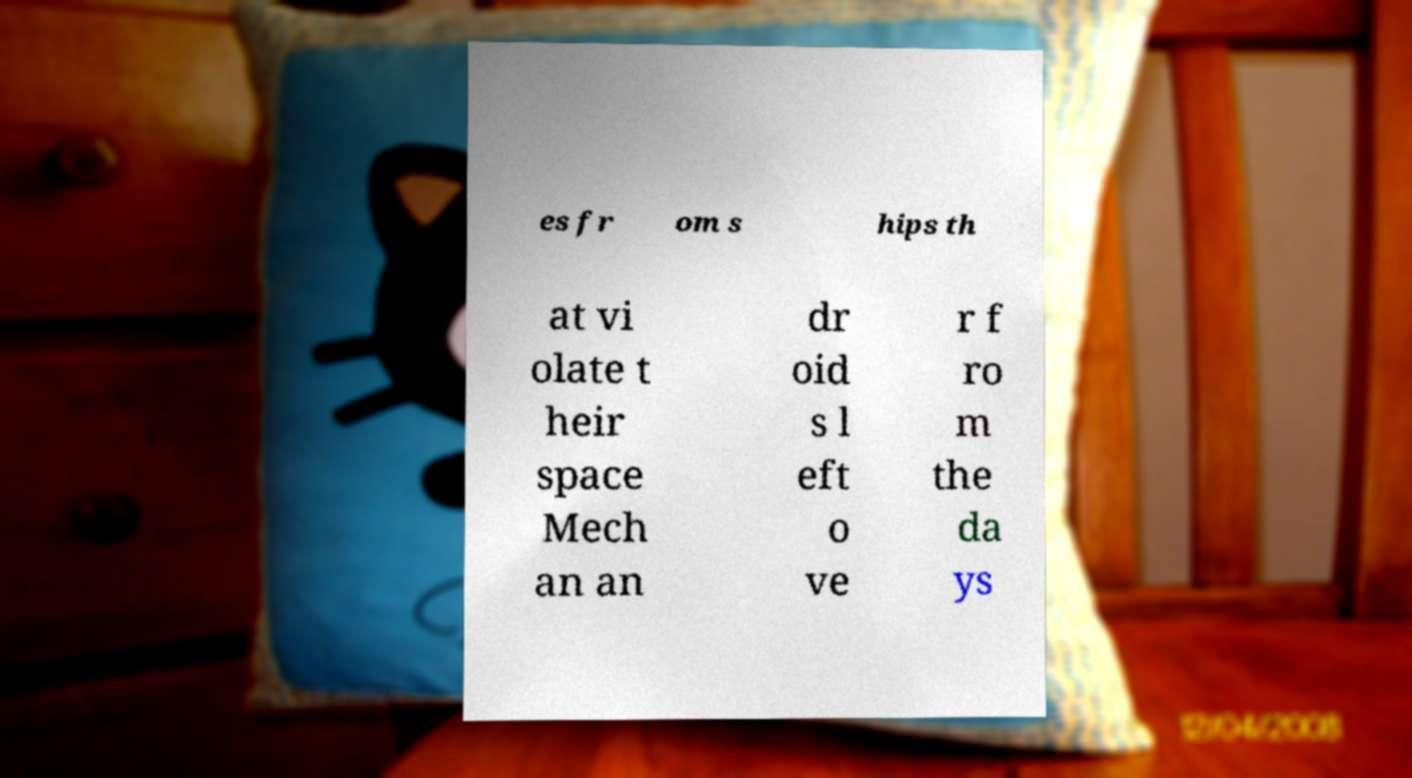Could you extract and type out the text from this image? es fr om s hips th at vi olate t heir space Mech an an dr oid s l eft o ve r f ro m the da ys 